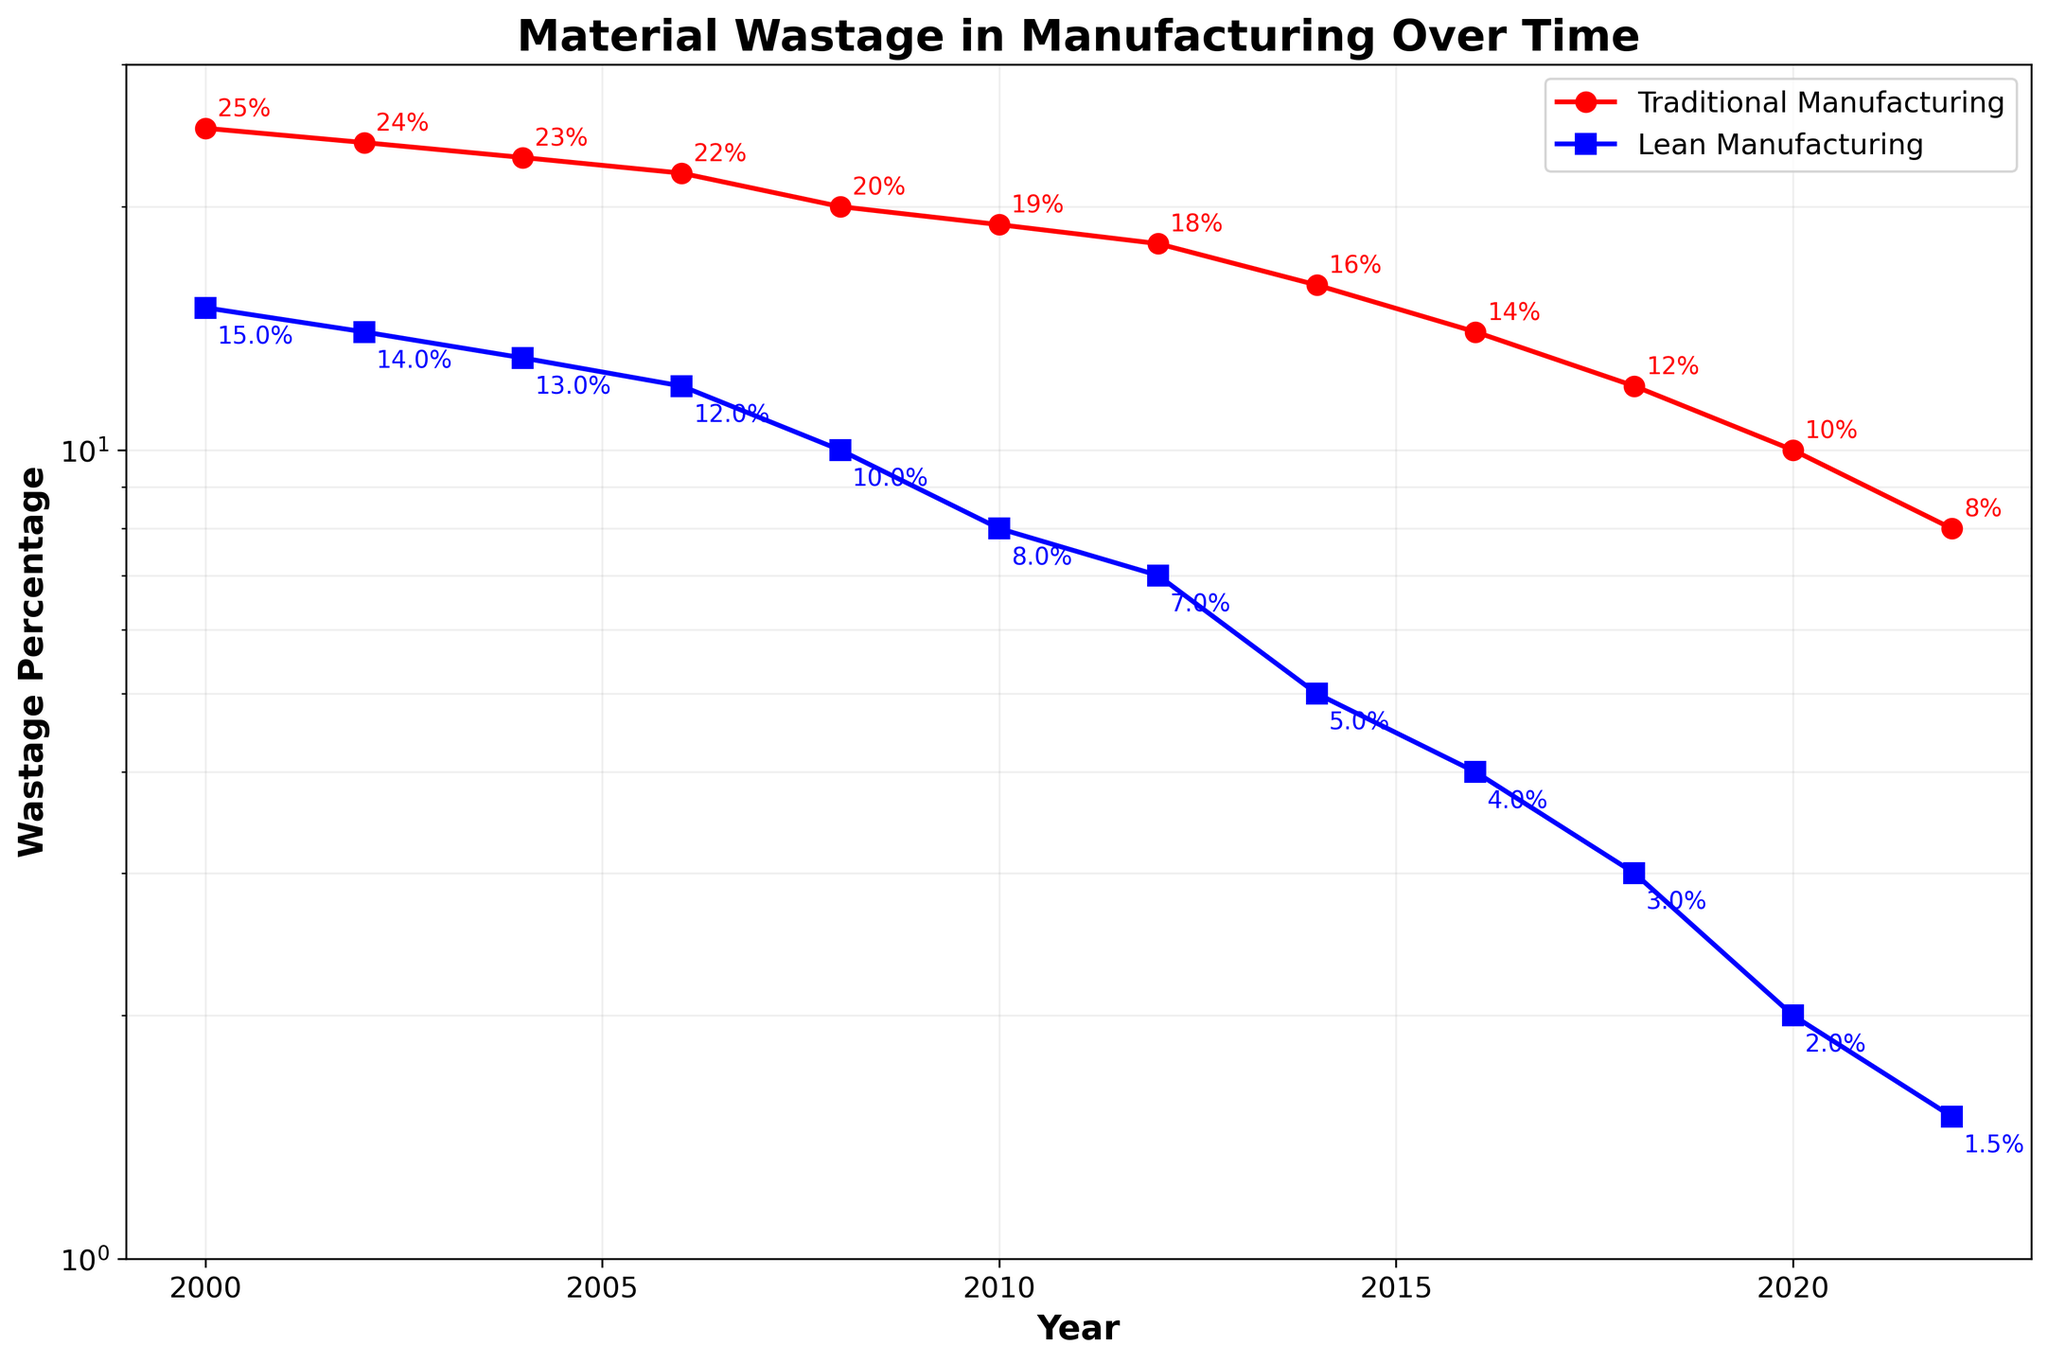What is the title of the figure? The title is located at the top of the figure and typically describes the overall content or main message of the plot.
Answer: Material Wastage in Manufacturing Over Time How many data points are there? The number of data points can be counted by seeing the markers for each year. Each marker represents one data point for both traditional and lean manufacturing lines.
Answer: 12 What is the traditional wastage percentage in 2000? Locate the year 2000 on the x-axis and find the corresponding point on the red line. Read the y-axis value at that point.
Answer: 25% What is the lean wastage percentage in 2022? Locate the year 2022 on the x-axis and find the corresponding point on the blue line. Read the y-axis value at that point.
Answer: 1.5% By how much did the traditional wastage percentage decrease from 2000 to 2008? Identify the traditional wastage percentage in 2000 and 2008, then subtract the value in 2008 from the value in 2000: 25% - 20%.
Answer: 5% Which year shows the biggest gap between traditional and lean wastage percentages? For each year, calculate the difference between the wastage percentages for traditional and lean manufacturing, and identify the year with the largest difference.
Answer: 2000 What is the average lean wastage percentage over all the years? Sum up all lean wastage percentages and divide by the number of years: (15 + 14 + 13 + 12 + 10 + 8 + 7 + 5 + 4 + 3 + 2 + 1.5)/12
Answer: 8.25% What trend can be observed for both traditional and lean wastage percentages over time? Observe the general direction of both lines from left to right, noting whether they increase, decrease, or remain stable.
Answer: Decreasing Does lean manufacturing always have a lower wastage percentage than traditional manufacturing during these years? Compare the corresponding data points of traditional and lean manufacturing for each year.
Answer: Yes What is the significance of the log scale in this plot? A log scale allows to better visualize differences in data that span several orders of magnitude by reducing wide ranges to more manageable ones. This highlights the relative changes and trends.
Answer: Better visualization of trends over a wide range 